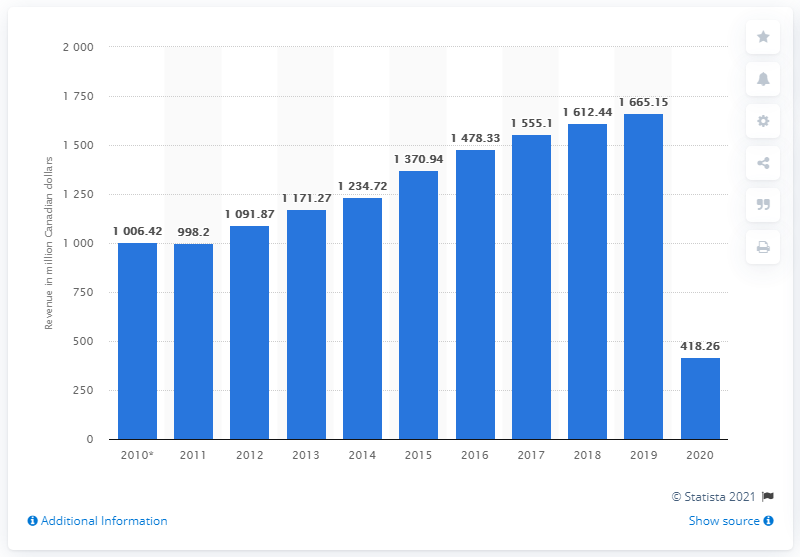Highlight a few significant elements in this photo. Cineplex's revenue a year earlier was 1665.15. 